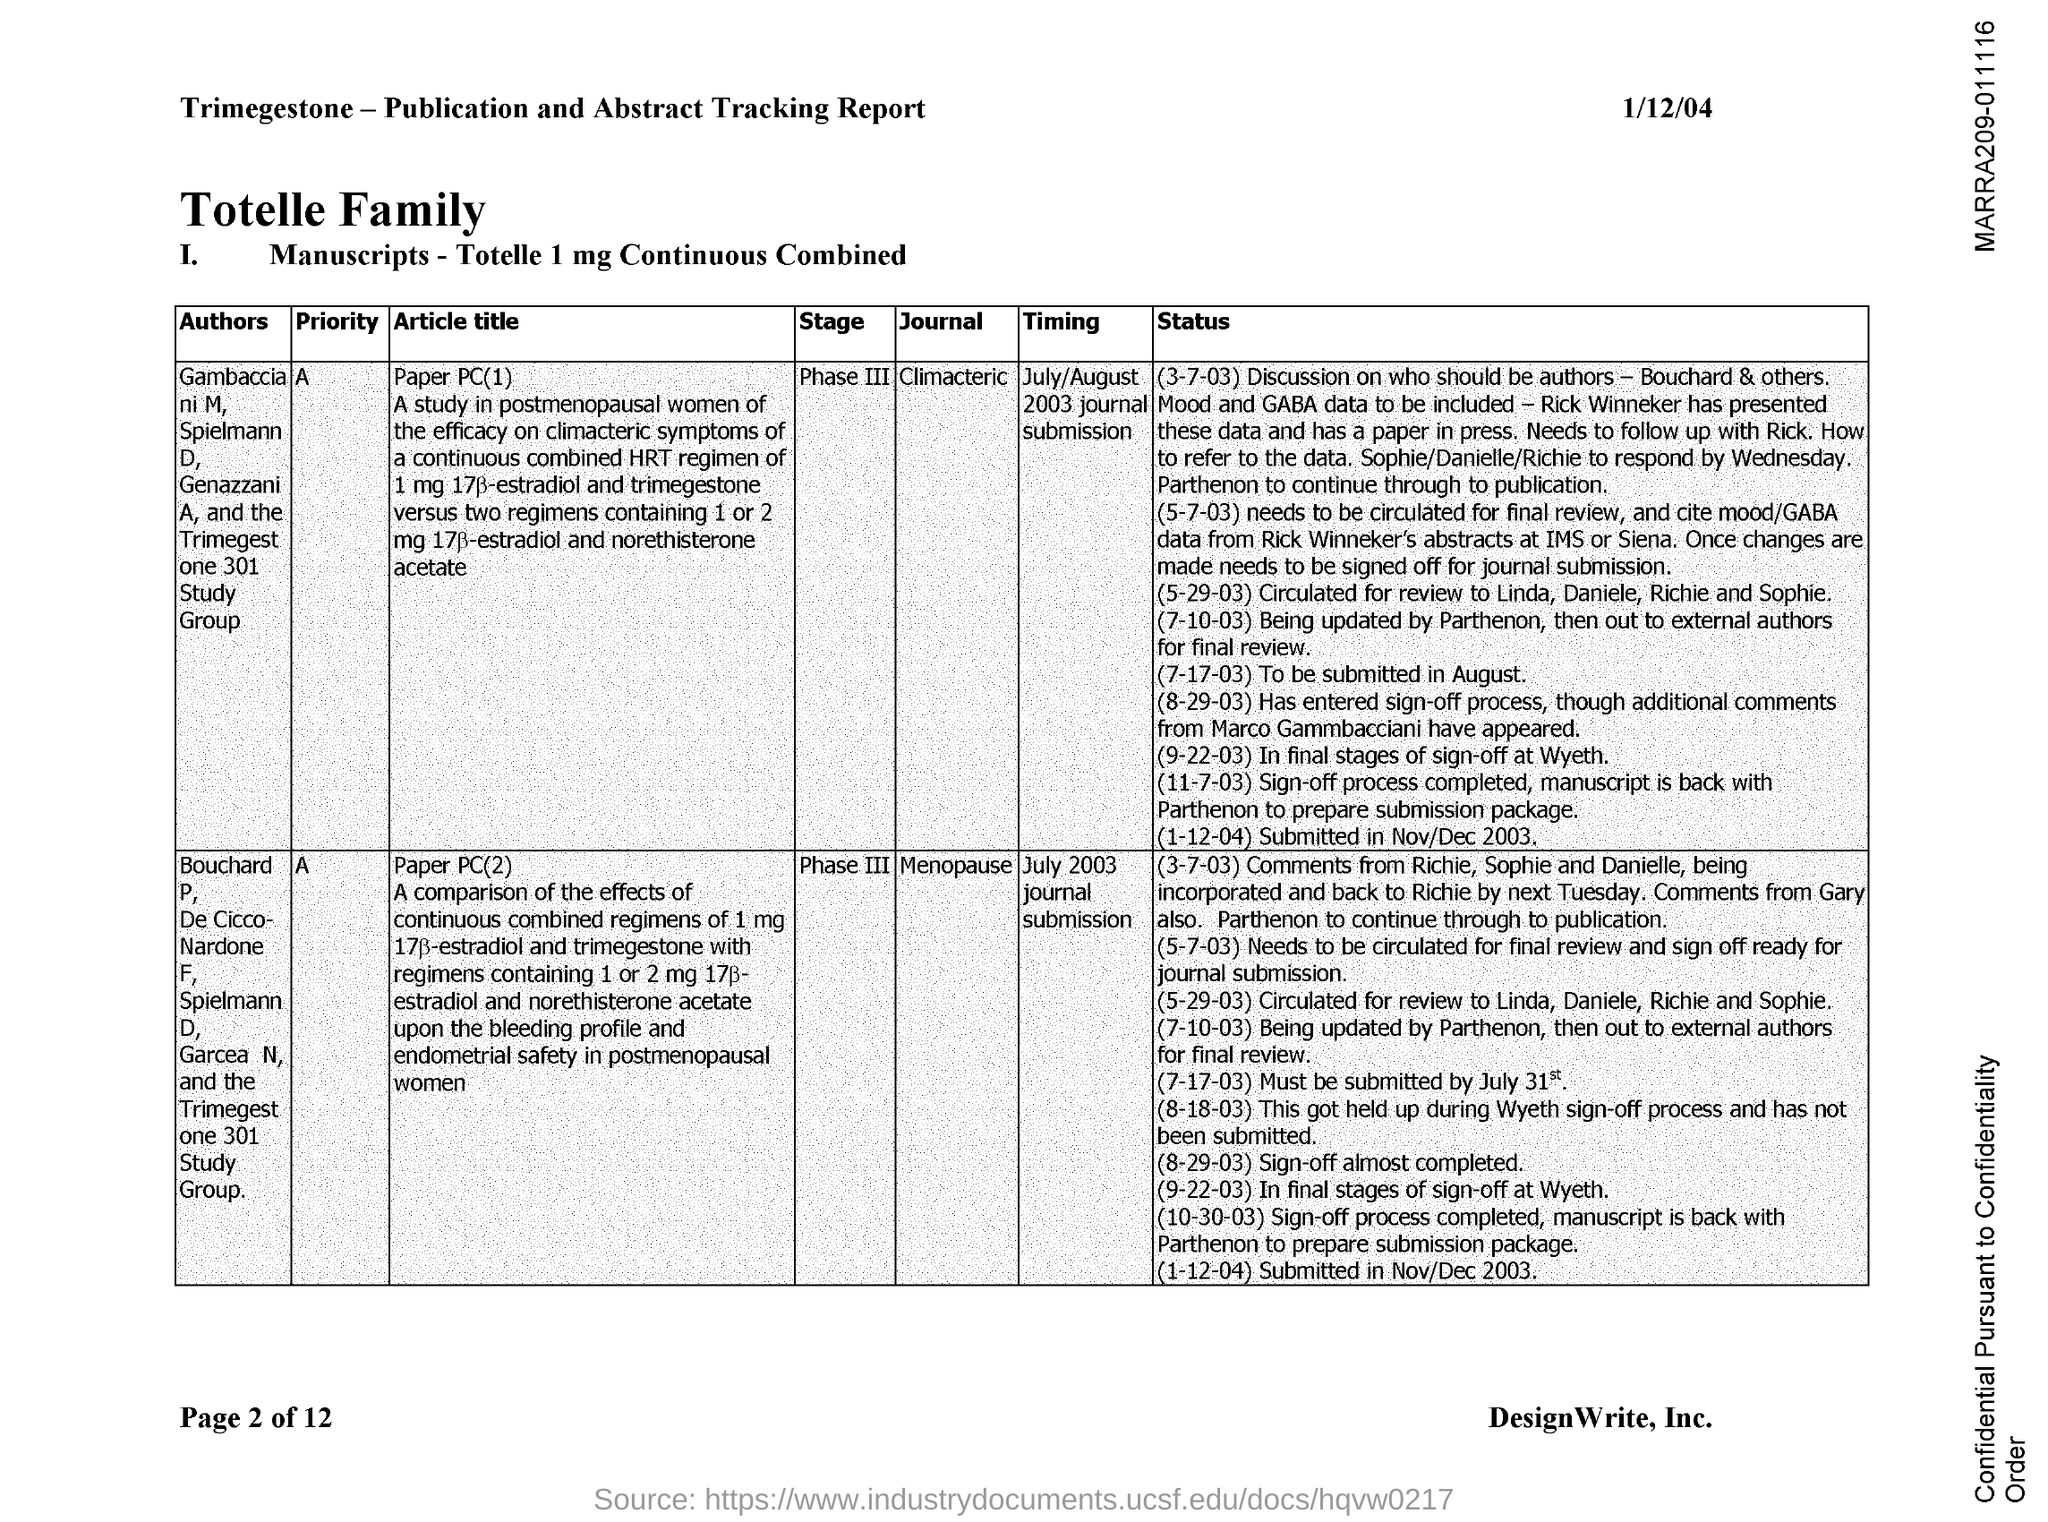Specify some key components in this picture. The document contains the date of 1/12/04. The article title "Menopause" is from the journal whose name is "What is the name of the journal whose Article title is paper PC(2)? The article in question is titled "paper PC(1)" and appears in the journal "Climacteric. 